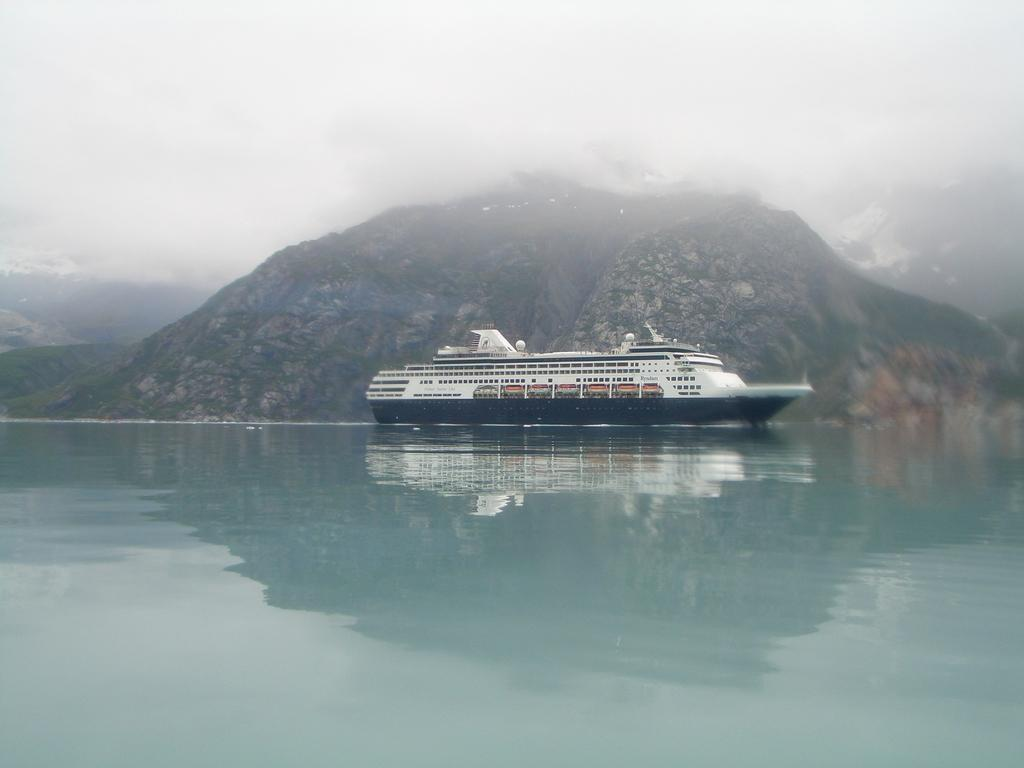What is the main subject of the image? The main subject of the image is a ship. Where is the ship located in the image? The ship is on the water in the image. What can be seen in the background of the image? There are mountains visible in the background of the image. What is visible at the top of the image? The sky is visible at the top of the image. What song is being played by the spiders in the image? There are no spiders or any indication of music in the image; it features a ship on the water with mountains in the background and the sky visible at the top. 